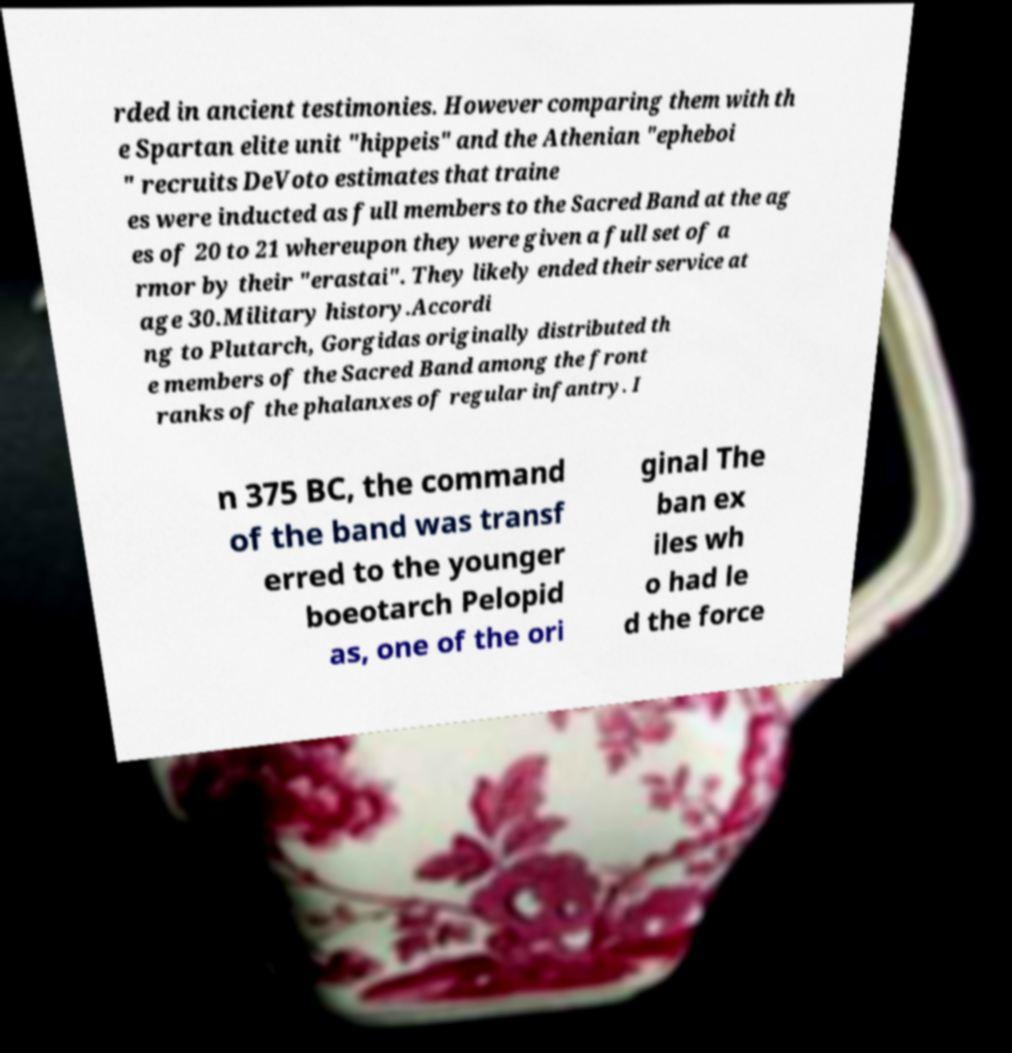Can you accurately transcribe the text from the provided image for me? rded in ancient testimonies. However comparing them with th e Spartan elite unit "hippeis" and the Athenian "epheboi " recruits DeVoto estimates that traine es were inducted as full members to the Sacred Band at the ag es of 20 to 21 whereupon they were given a full set of a rmor by their "erastai". They likely ended their service at age 30.Military history.Accordi ng to Plutarch, Gorgidas originally distributed th e members of the Sacred Band among the front ranks of the phalanxes of regular infantry. I n 375 BC, the command of the band was transf erred to the younger boeotarch Pelopid as, one of the ori ginal The ban ex iles wh o had le d the force 